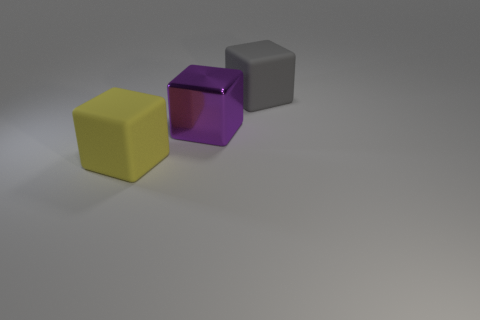Add 3 big metallic blocks. How many objects exist? 6 Subtract all small red metallic cubes. Subtract all large rubber blocks. How many objects are left? 1 Add 2 large gray matte blocks. How many large gray matte blocks are left? 3 Add 3 yellow rubber cubes. How many yellow rubber cubes exist? 4 Subtract 1 yellow cubes. How many objects are left? 2 